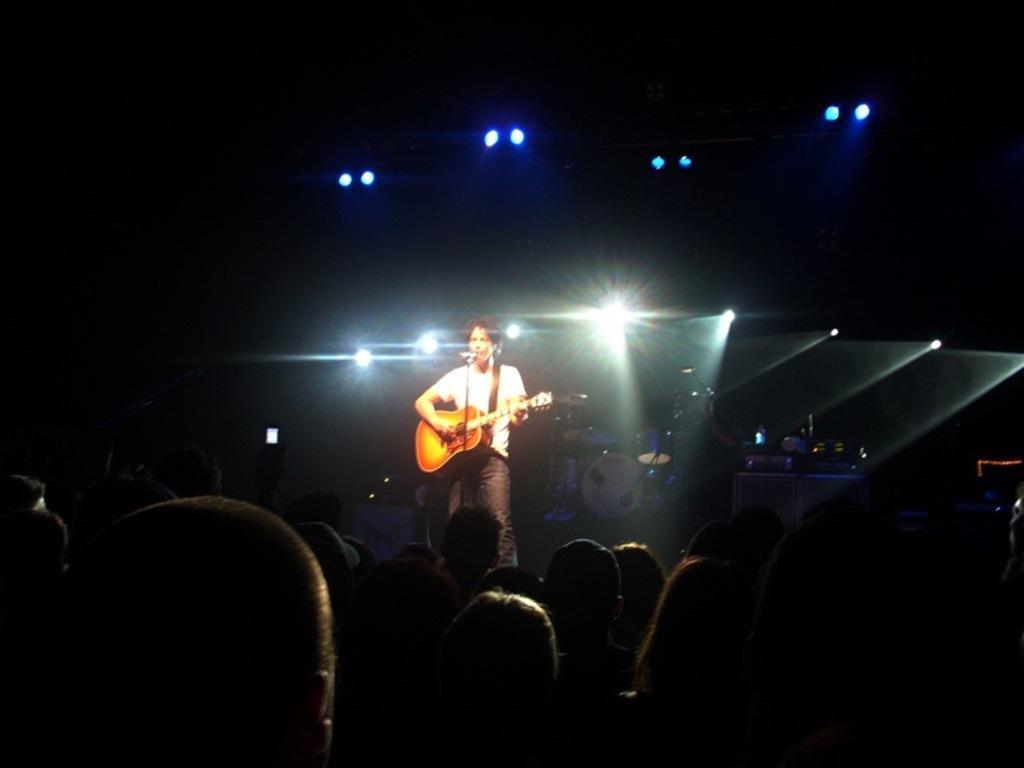Can you describe this image briefly? The person wearing white shirt is playing guitar and singing in front of the mike and there are drums behind him and there are group of people in front of him. 